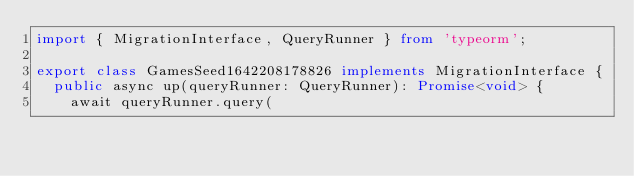Convert code to text. <code><loc_0><loc_0><loc_500><loc_500><_TypeScript_>import { MigrationInterface, QueryRunner } from 'typeorm';

export class GamesSeed1642208178826 implements MigrationInterface {
  public async up(queryRunner: QueryRunner): Promise<void> {
    await queryRunner.query(</code> 